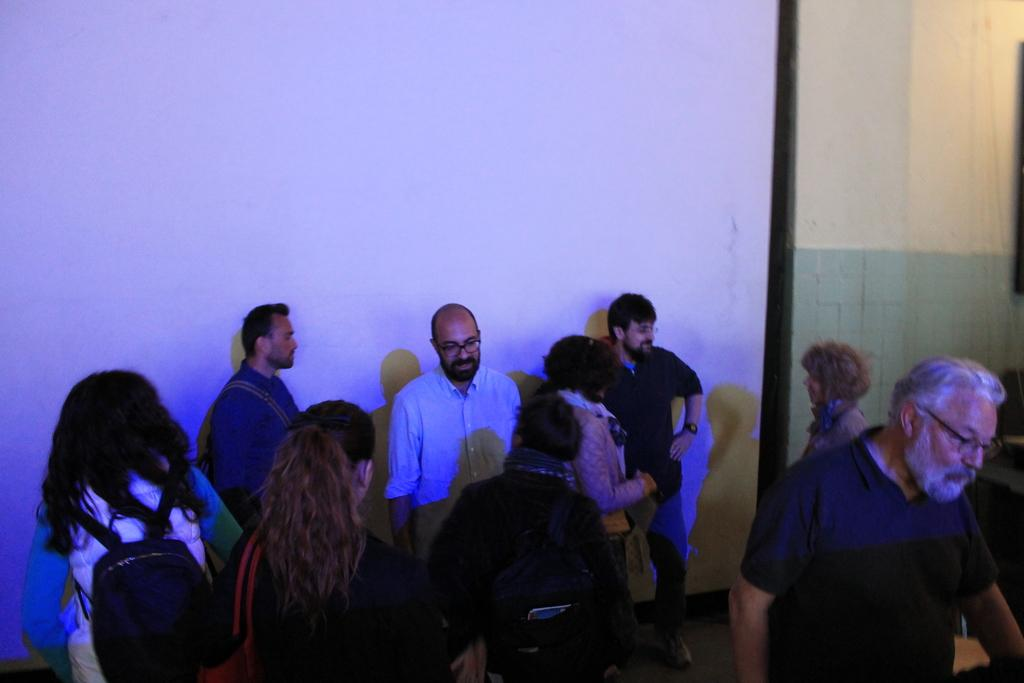Who or what can be seen in the image? There are people in the image. Where are the people located? The people are standing in a room. What are some of the people wearing? Some of the people are wearing backpacks. What type of cow can be seen resting in the room with the people? There is no cow present in the image; it only features people standing in a room. 